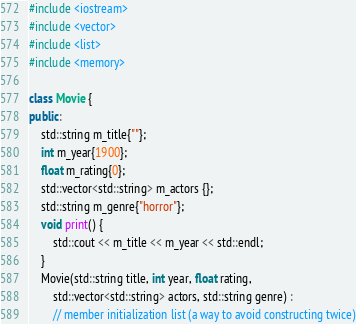Convert code to text. <code><loc_0><loc_0><loc_500><loc_500><_C++_>#include <iostream>
#include <vector>
#include <list>
#include <memory>

class Movie {
public:
    std::string m_title{""};
    int m_year{1900};
    float m_rating{0};
    std::vector<std::string> m_actors {};
    std::string m_genre{"horror"};
    void print() {
        std::cout << m_title << m_year << std::endl;
    }
    Movie(std::string title, int year, float rating,
        std::vector<std::string> actors, std::string genre) :
        // member initialization list (a way to avoid constructing twice)</code> 